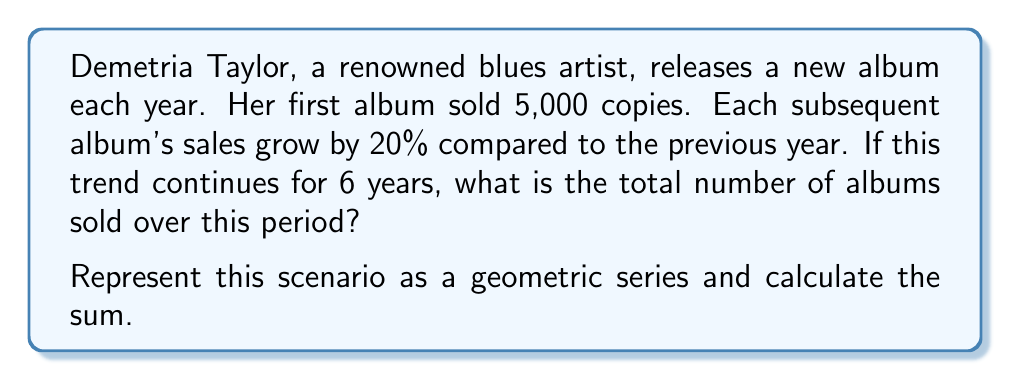Help me with this question. Let's approach this step-by-step:

1) First, we need to identify the elements of our geometric series:
   - $a$: first term (initial album sales) = 5,000
   - $r$: common ratio (growth rate) = 1.20 (20% increase = 1 + 0.20)
   - $n$: number of terms (years) = 6

2) The formula for the sum of a geometric series is:

   $$S_n = \frac{a(1-r^n)}{1-r}$$

   Where $S_n$ is the sum of the first $n$ terms.

3) Let's substitute our values:

   $$S_6 = \frac{5000(1-1.20^6)}{1-1.20}$$

4) Now, let's calculate $1.20^6$:
   
   $$1.20^6 \approx 2.9859$$

5) Substituting this back:

   $$S_6 = \frac{5000(1-2.9859)}{1-1.20} = \frac{5000(-1.9859)}{-0.20}$$

6) Simplifying:

   $$S_6 = \frac{9929.5}{0.20} = 49647.5$$

7) Since we're dealing with whole album sales, we round to the nearest whole number.
Answer: The total number of albums sold over the 6-year period is approximately 49,648. 